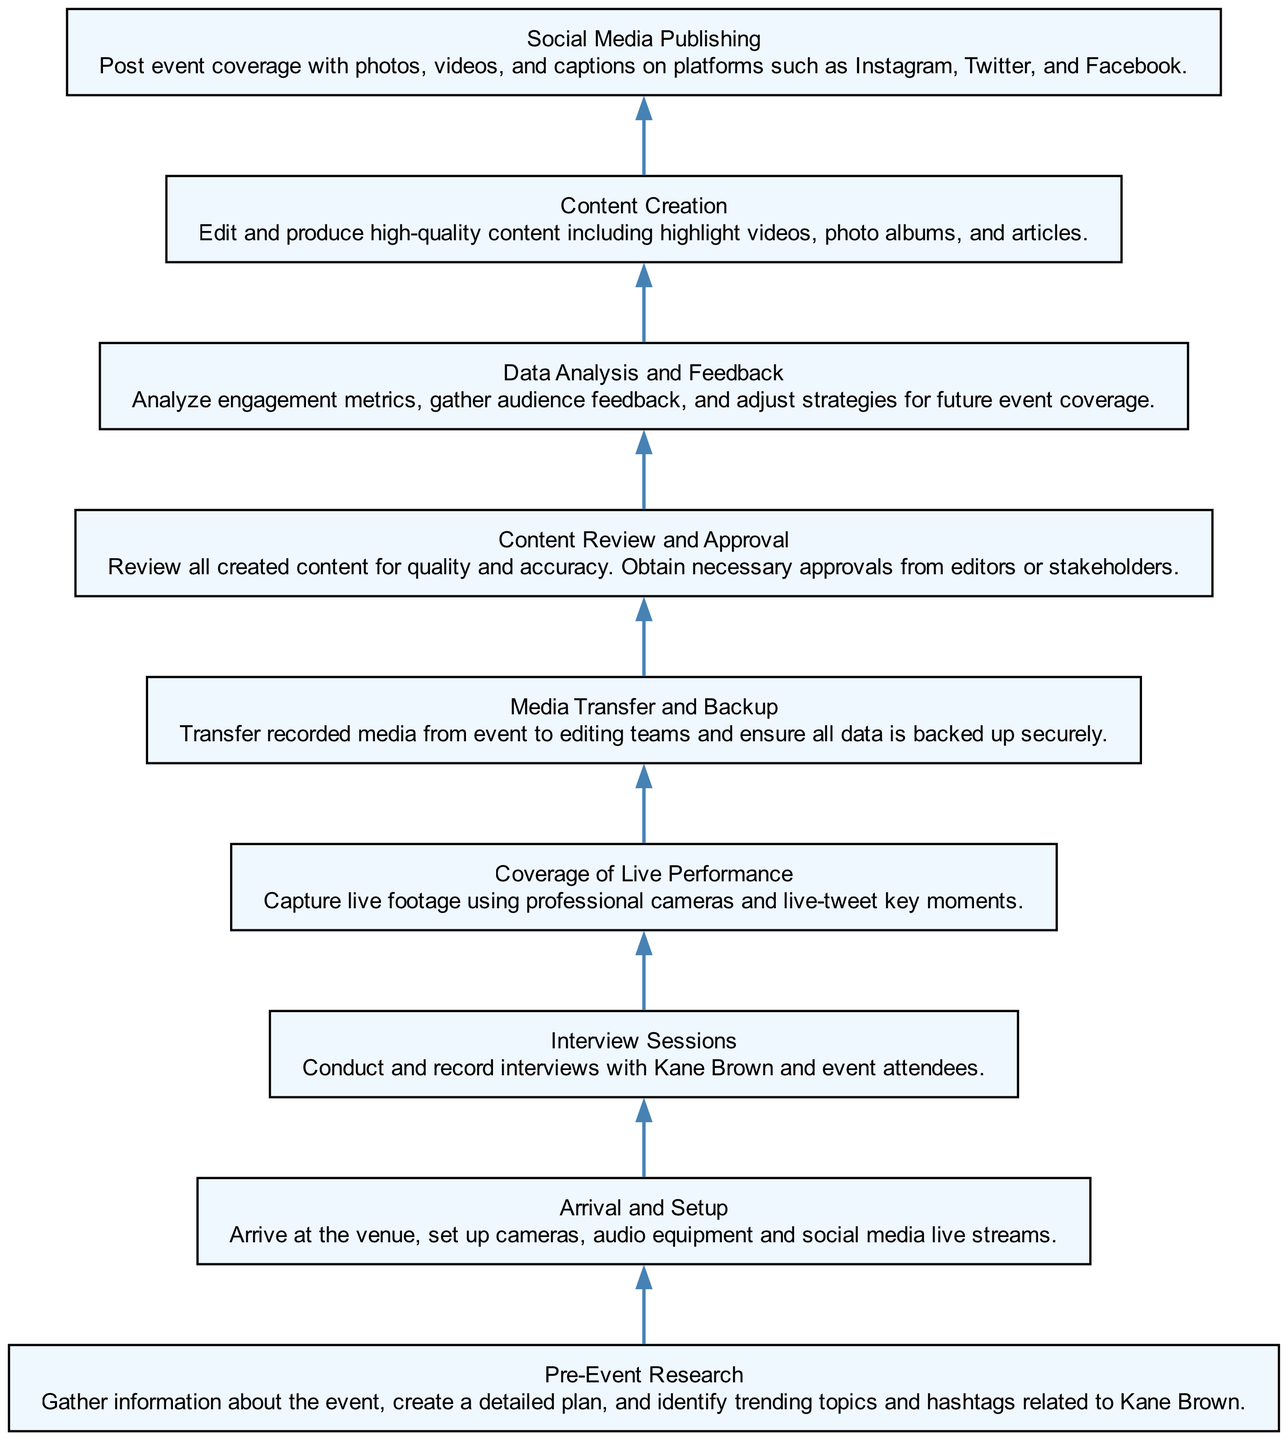What’s the first step in the event coverage process? The diagrams show that the process begins with "Pre-Event Research," which is at the bottom of the flowchart and is identified as a necessary initial step.
Answer: Pre-Event Research How many total nodes are present in the diagram? By counting all elements in the provided data, there are nine distinct nodes representing different steps in the coverage process.
Answer: 9 Which node is directly connected to the "Media Transfer and Backup"? Following the directional edges in the flowchart from "Media Transfer and Backup," the next node above it is "Content Review and Approval," indicating a direct connection.
Answer: Content Review and Approval What type of content is produced before "Social Media Publishing"? The flow indicates that "Content Creation" occurs just before "Social Media Publishing," aligning it as the content produced before this step in the process.
Answer: Content Creation What is the purpose of the "Data Analysis and Feedback" step? The diagram clearly shows that "Data Analysis and Feedback" is meant for analyzing engagement metrics and gathering audience feedback to improve future events, serving an evaluative role in the process.
Answer: Analyze engagement metrics Which two steps directly involve interaction with Kane Brown? The "Interview Sessions" involve directly interacting with Kane Brown and the event attendees, while "Coverage of Live Performance" also involves capturing him during the event, highlighting his participation in both steps.
Answer: Interview Sessions and Coverage of Live Performance What is the role of "Content Review and Approval"? This step involves reviewing all content for quality and accuracy, ensuring that necessary approvals are obtained from relevant editors or stakeholders prior to publication.
Answer: Quality and accuracy review Which node would you reach after "Arrival and Setup"? Based on the directional flow, the next step after "Arrival and Setup" is "Interview Sessions," indicating that interviews follow the setup process at the event.
Answer: Interview Sessions 